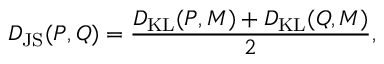<formula> <loc_0><loc_0><loc_500><loc_500>D _ { J S } ( P , Q ) = \frac { D _ { K L } ( P , M ) + D _ { K L } ( Q , M ) } { 2 } ,</formula> 